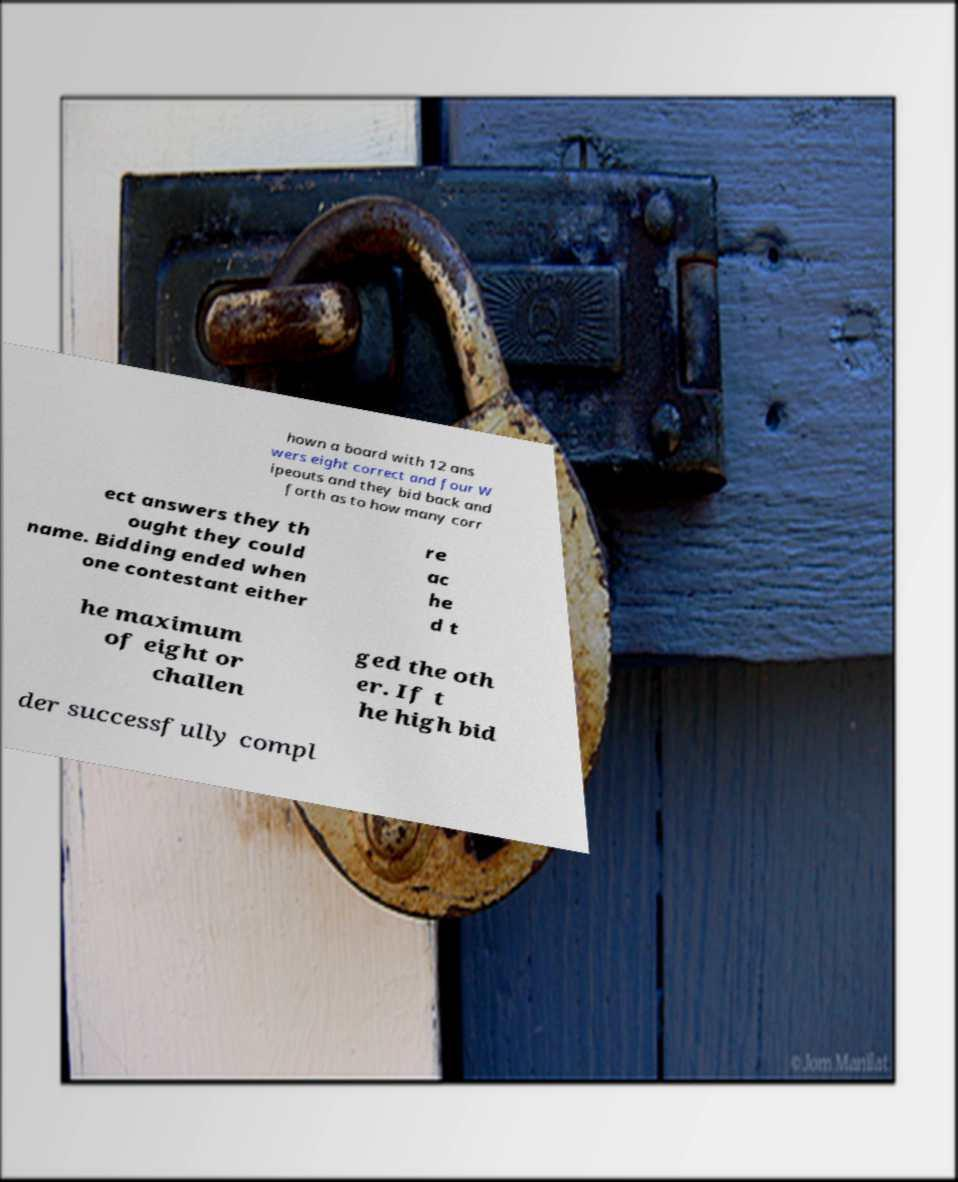Could you assist in decoding the text presented in this image and type it out clearly? hown a board with 12 ans wers eight correct and four W ipeouts and they bid back and forth as to how many corr ect answers they th ought they could name. Bidding ended when one contestant either re ac he d t he maximum of eight or challen ged the oth er. If t he high bid der successfully compl 